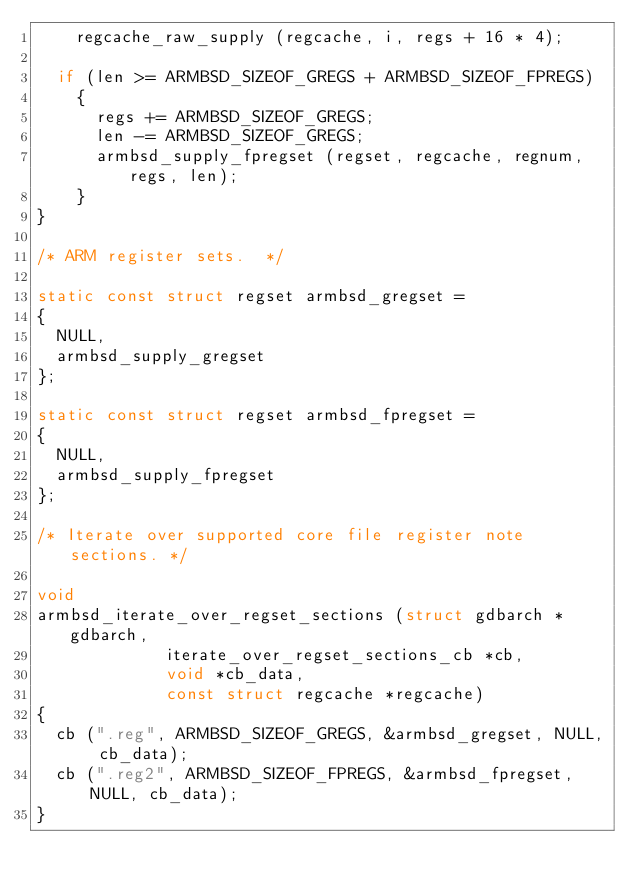<code> <loc_0><loc_0><loc_500><loc_500><_C_>    regcache_raw_supply (regcache, i, regs + 16 * 4);

  if (len >= ARMBSD_SIZEOF_GREGS + ARMBSD_SIZEOF_FPREGS)
    {
      regs += ARMBSD_SIZEOF_GREGS;
      len -= ARMBSD_SIZEOF_GREGS;
      armbsd_supply_fpregset (regset, regcache, regnum, regs, len);
    }
}

/* ARM register sets.  */

static const struct regset armbsd_gregset =
{
  NULL,
  armbsd_supply_gregset
};

static const struct regset armbsd_fpregset =
{
  NULL,
  armbsd_supply_fpregset
};

/* Iterate over supported core file register note sections. */

void
armbsd_iterate_over_regset_sections (struct gdbarch *gdbarch,
				     iterate_over_regset_sections_cb *cb,
				     void *cb_data,
				     const struct regcache *regcache)
{
  cb (".reg", ARMBSD_SIZEOF_GREGS, &armbsd_gregset, NULL, cb_data);
  cb (".reg2", ARMBSD_SIZEOF_FPREGS, &armbsd_fpregset, NULL, cb_data);
}
</code> 